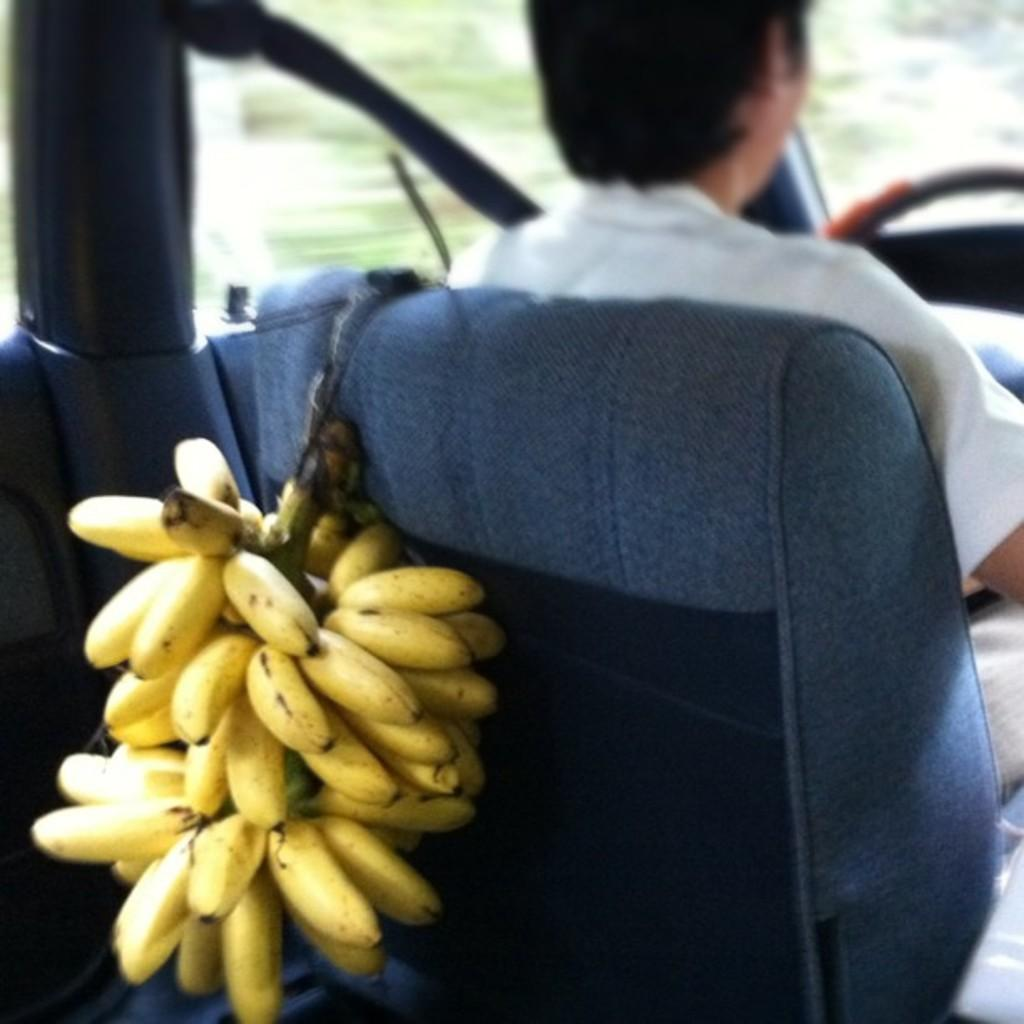What is the person in the image doing? The person is sitting on a seat. What is hanging on the seat in the image? There is a bunch of bananas hanging on the seat. What rhythm does the person in the image use to add more bananas to the bunch? There is no indication in the image that the person is adding more bananas to the bunch, nor is there any mention of rhythm. 